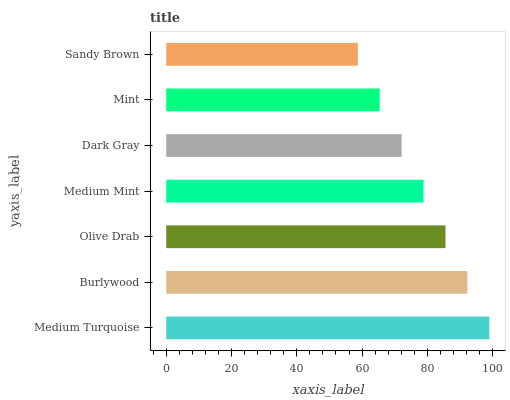Is Sandy Brown the minimum?
Answer yes or no. Yes. Is Medium Turquoise the maximum?
Answer yes or no. Yes. Is Burlywood the minimum?
Answer yes or no. No. Is Burlywood the maximum?
Answer yes or no. No. Is Medium Turquoise greater than Burlywood?
Answer yes or no. Yes. Is Burlywood less than Medium Turquoise?
Answer yes or no. Yes. Is Burlywood greater than Medium Turquoise?
Answer yes or no. No. Is Medium Turquoise less than Burlywood?
Answer yes or no. No. Is Medium Mint the high median?
Answer yes or no. Yes. Is Medium Mint the low median?
Answer yes or no. Yes. Is Olive Drab the high median?
Answer yes or no. No. Is Sandy Brown the low median?
Answer yes or no. No. 